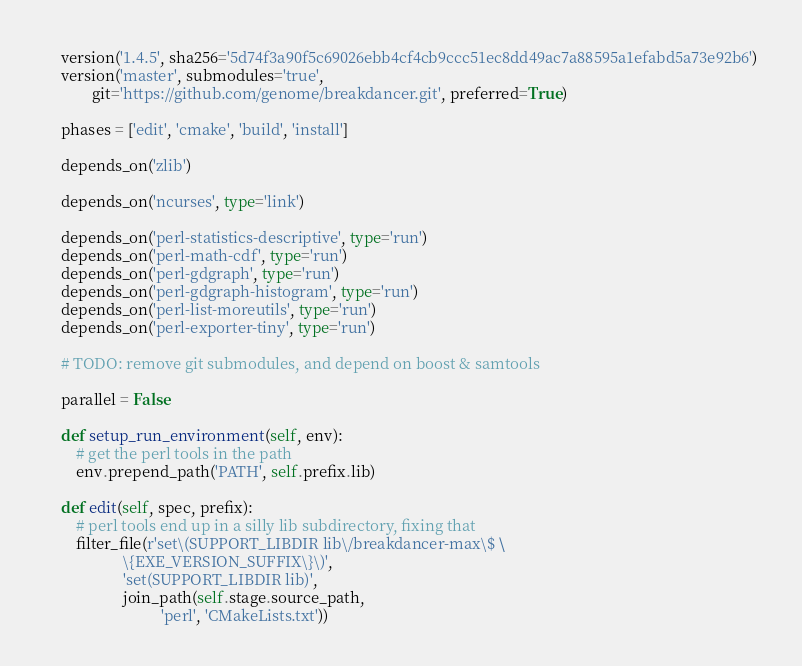Convert code to text. <code><loc_0><loc_0><loc_500><loc_500><_Python_>    version('1.4.5', sha256='5d74f3a90f5c69026ebb4cf4cb9ccc51ec8dd49ac7a88595a1efabd5a73e92b6')
    version('master', submodules='true',
            git='https://github.com/genome/breakdancer.git', preferred=True)

    phases = ['edit', 'cmake', 'build', 'install']

    depends_on('zlib')

    depends_on('ncurses', type='link')

    depends_on('perl-statistics-descriptive', type='run')
    depends_on('perl-math-cdf', type='run')
    depends_on('perl-gdgraph', type='run')
    depends_on('perl-gdgraph-histogram', type='run')
    depends_on('perl-list-moreutils', type='run')
    depends_on('perl-exporter-tiny', type='run')

    # TODO: remove git submodules, and depend on boost & samtools

    parallel = False

    def setup_run_environment(self, env):
        # get the perl tools in the path
        env.prepend_path('PATH', self.prefix.lib)

    def edit(self, spec, prefix):
        # perl tools end up in a silly lib subdirectory, fixing that
        filter_file(r'set\(SUPPORT_LIBDIR lib\/breakdancer-max\$ \
                    \{EXE_VERSION_SUFFIX\}\)',
                    'set(SUPPORT_LIBDIR lib)',
                    join_path(self.stage.source_path,
                              'perl', 'CMakeLists.txt'))
</code> 